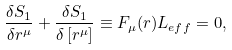Convert formula to latex. <formula><loc_0><loc_0><loc_500><loc_500>\frac { \delta S _ { 1 } } { \delta r ^ { \mu } } + \frac { \delta S _ { 1 } } { \delta \left [ r ^ { \mu } \right ] } \equiv F _ { \mu } ( r ) L _ { e f f } = 0 ,</formula> 